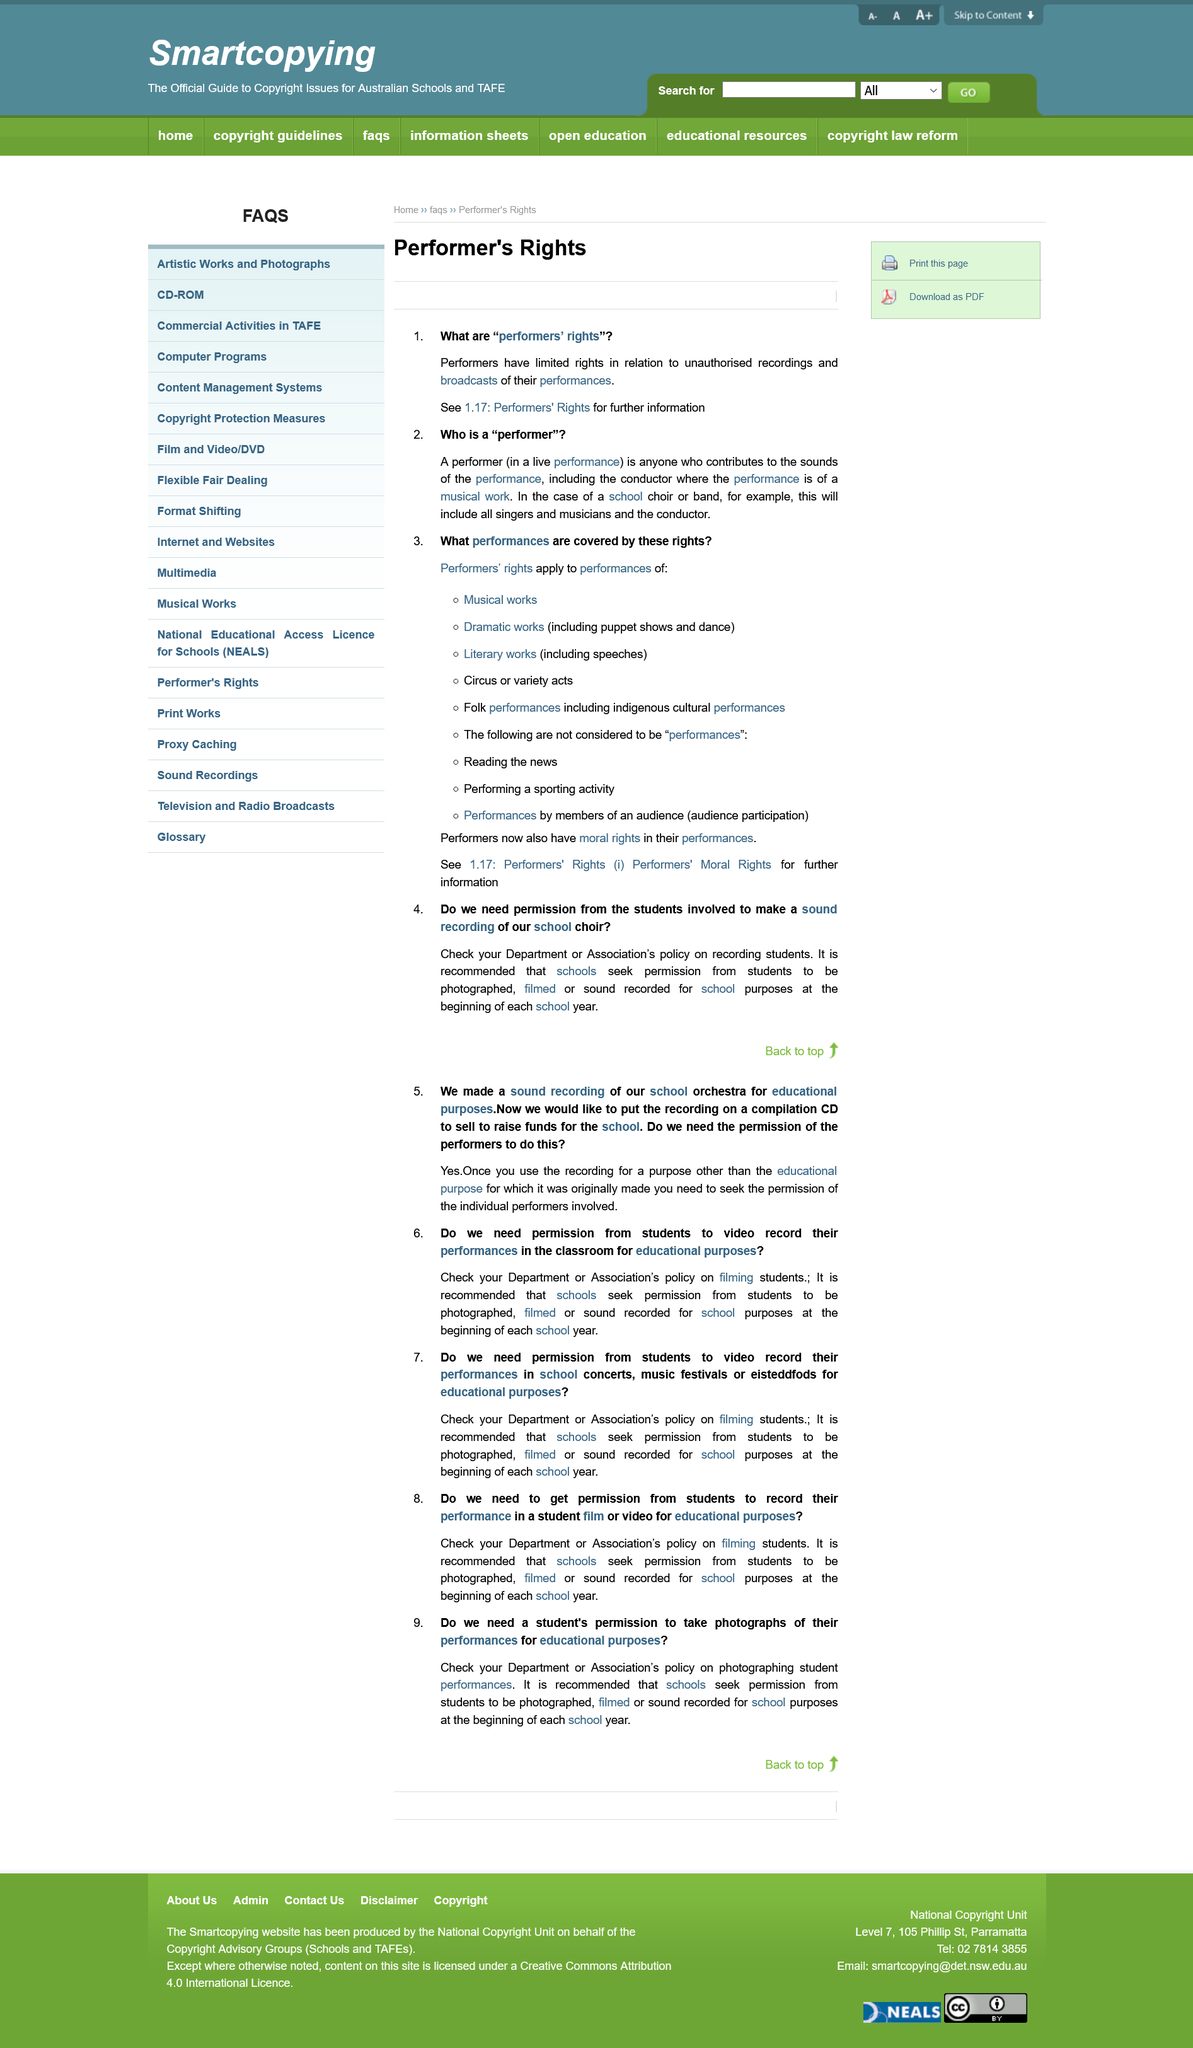Indicate a few pertinent items in this graphic. All singers and musicians in a school choir are regarded as performers. Yes, musicians in a band have performers' rights in relation to unauthorized recordings of their performances. 